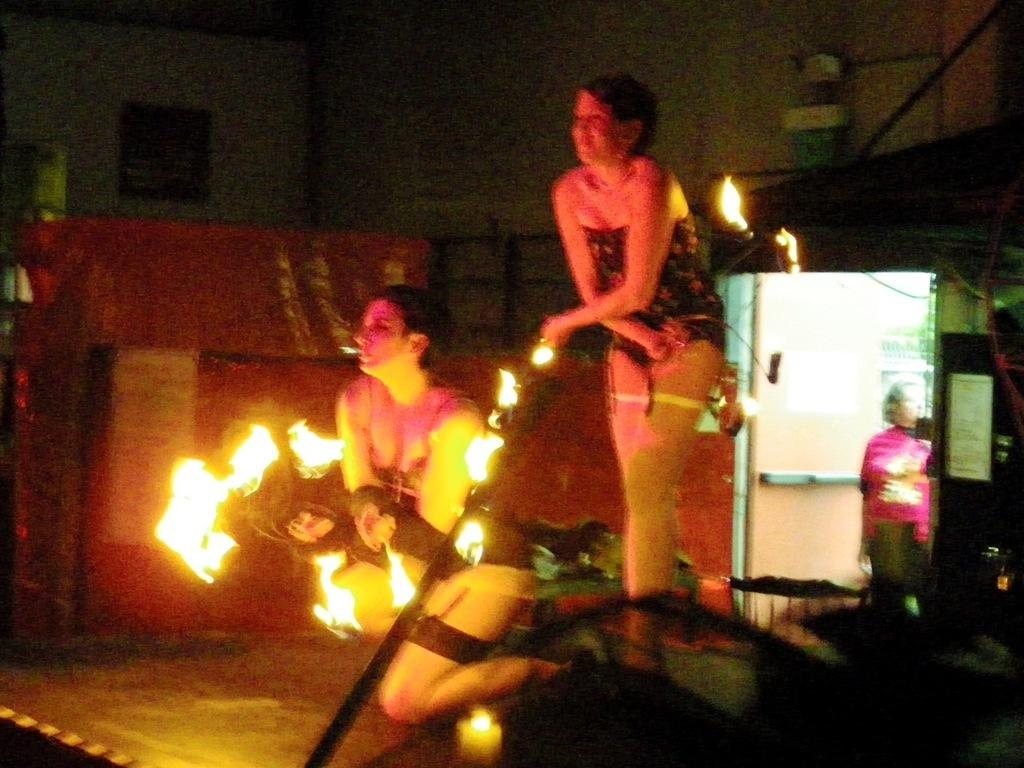How many people are in the image? There are two persons in the image. What are the two persons doing in the image? The two persons are juggling fire. Can you describe the background of the image? There is another person standing in the background, and there is a door visible in the background. What type of secretary can be seen working at the playground in the image? There is no secretary or playground present in the image; it features two persons juggling fire and a background with another person and a door. Is there a ship visible in the image? There is no ship present in the image. 